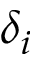Convert formula to latex. <formula><loc_0><loc_0><loc_500><loc_500>\delta _ { i }</formula> 